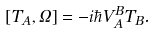Convert formula to latex. <formula><loc_0><loc_0><loc_500><loc_500>[ T _ { A } , \Omega ] = - i \hbar { V } ^ { B } _ { A } T _ { B } .</formula> 